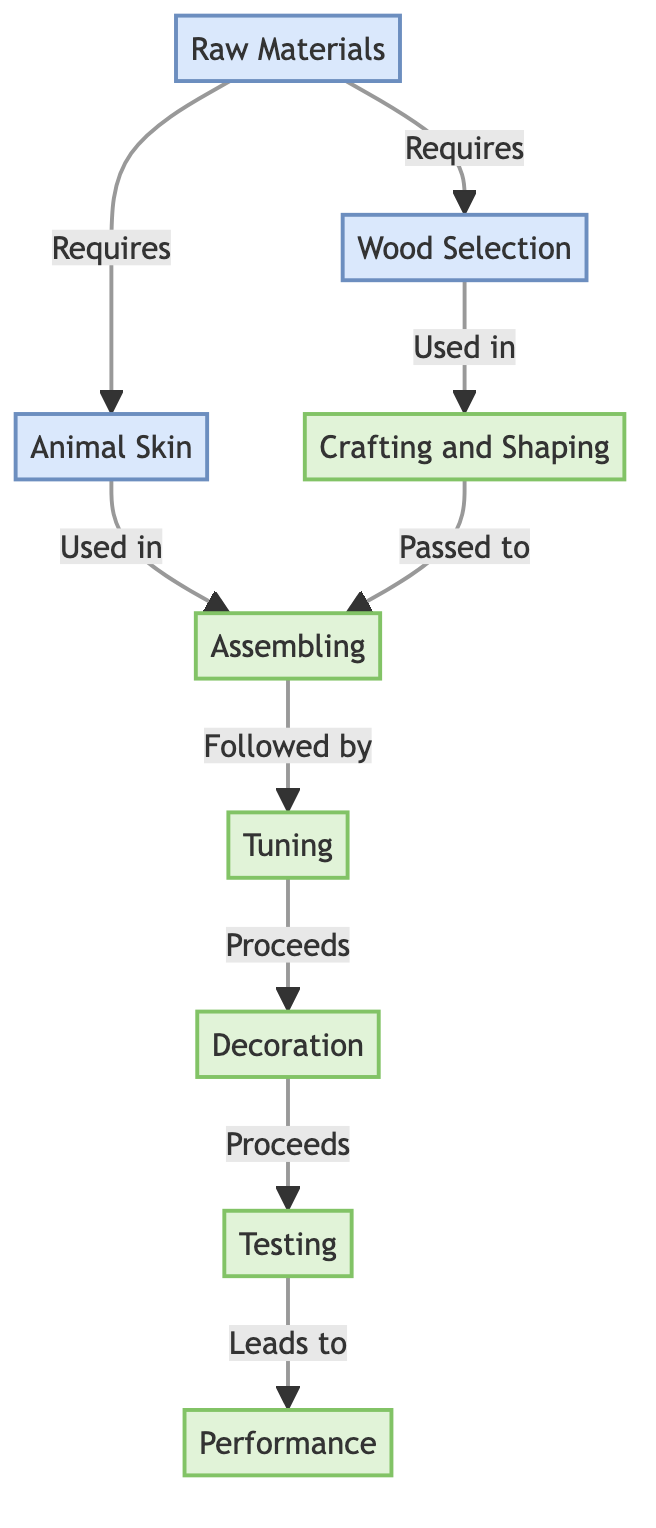What are the two primary raw materials listed in the diagram? The diagram specifically mentions "Wood Selection" and "Animal Skin" as the two primary raw materials required.
Answer: Wood Selection, Animal Skin How many processing steps are included in the lifecycle? The diagram shows five processing steps: Crafting and Shaping, Assembling, Tuning, Decoration, and Testing.
Answer: Five What is the final step before performance in the lifecycle of the percussion instrument? According to the diagram, "Testing" is the final step that precedes "Performance."
Answer: Testing Which step directly follows "Assembling" in the lifecycle of the instrument? The diagram indicates that "Tuning" directly follows "Assembling."
Answer: Tuning What type of relationship exists between "Crafting and Shaping" and "Assembling"? Based on the diagram, the relationship is that "Crafting and Shaping" is used in "Assembling," indicating a progressive step in the process.
Answer: Used in What is the sequence of steps starting from "Raw Materials" to "Performance"? To arrive at "Performance," the sequence is: Raw Materials → Wood Selection, Animal Skin → Crafting and Shaping → Assembling → Tuning → Decoration → Testing → Performance.
Answer: Raw Materials → Performance How many nodes represent the processing stages in the lifecycle? The processing stages represented in the diagram are five nodes: Crafting and Shaping, Assembling, Tuning, Decoration, and Testing.
Answer: Five Which step comes after "Decoration" in the lifecycle? The diagram specifies that "Testing" follows "Decoration."
Answer: Testing What type of diagram is illustrated here, and what is its focus? The diagram type is a Natural Science Diagram, focusing on the lifecycle of a traditional percussion instrument from raw materials to performance.
Answer: Natural Science Diagram 